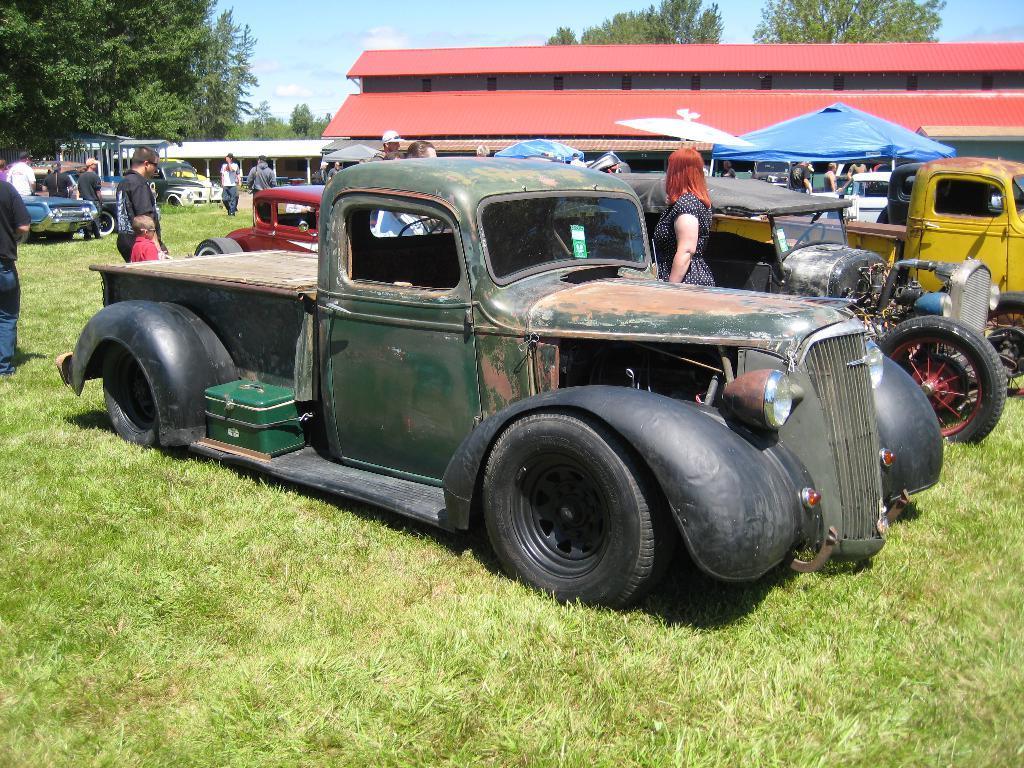Describe this image in one or two sentences. In this image there is sky, there is a building, there are treeś, there are vehicles, there are personś, there is grass. 